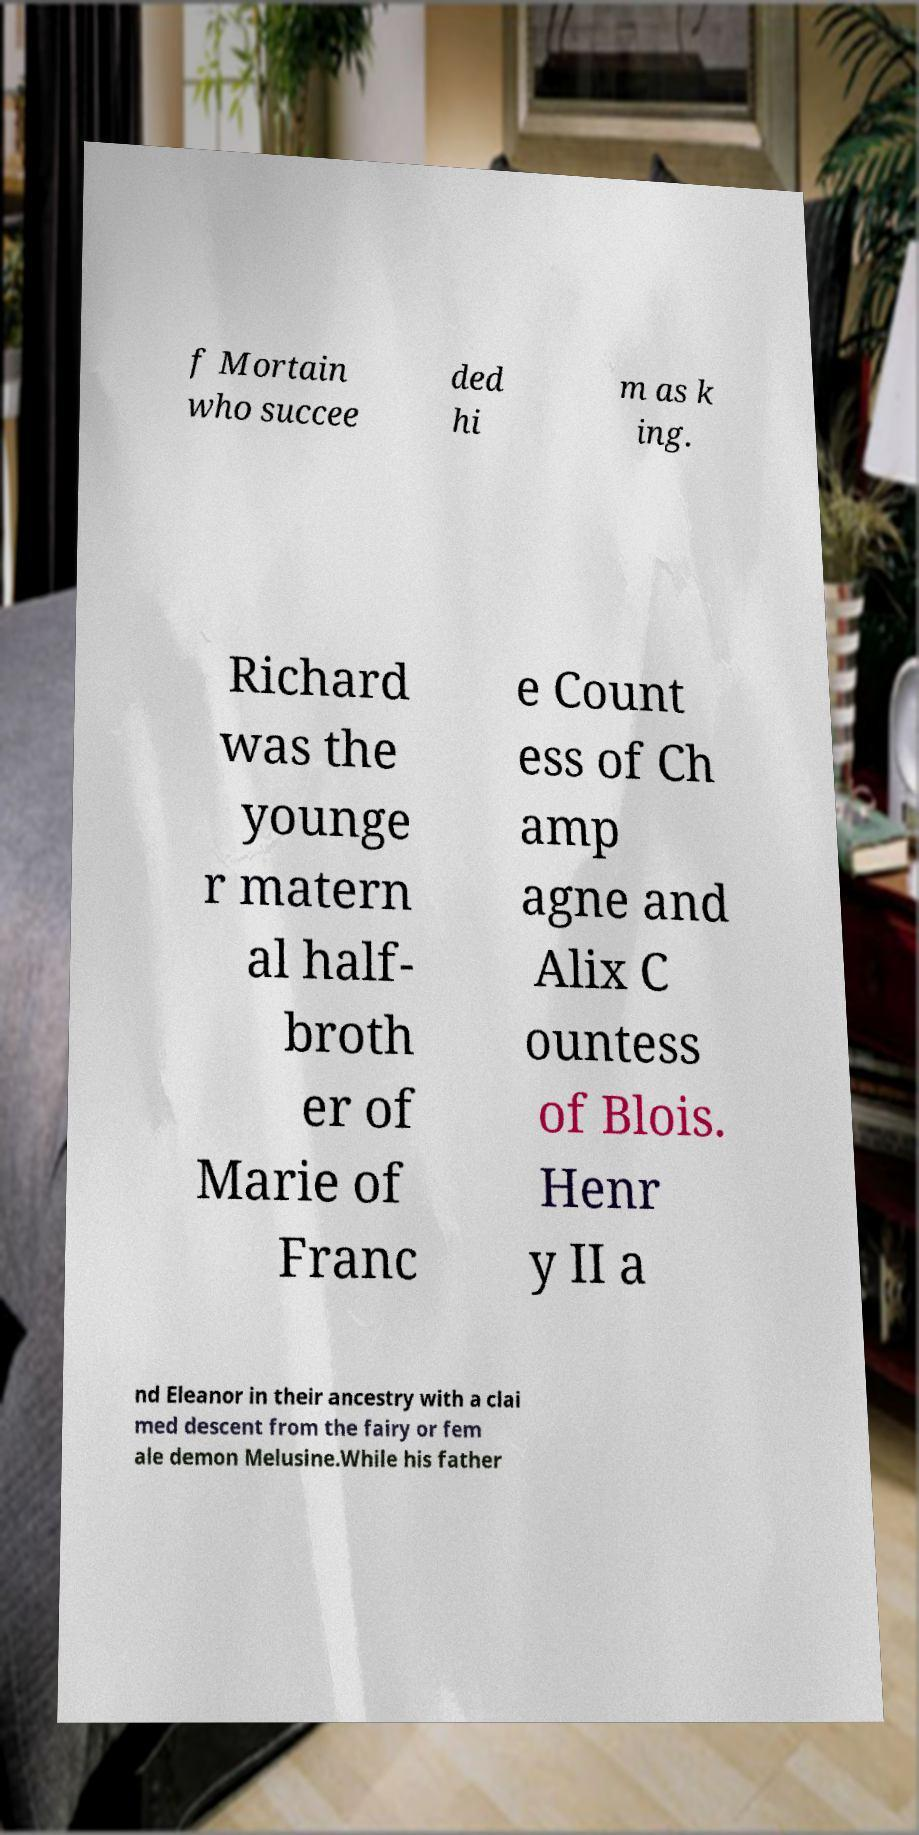I need the written content from this picture converted into text. Can you do that? f Mortain who succee ded hi m as k ing. Richard was the younge r matern al half- broth er of Marie of Franc e Count ess of Ch amp agne and Alix C ountess of Blois. Henr y II a nd Eleanor in their ancestry with a clai med descent from the fairy or fem ale demon Melusine.While his father 